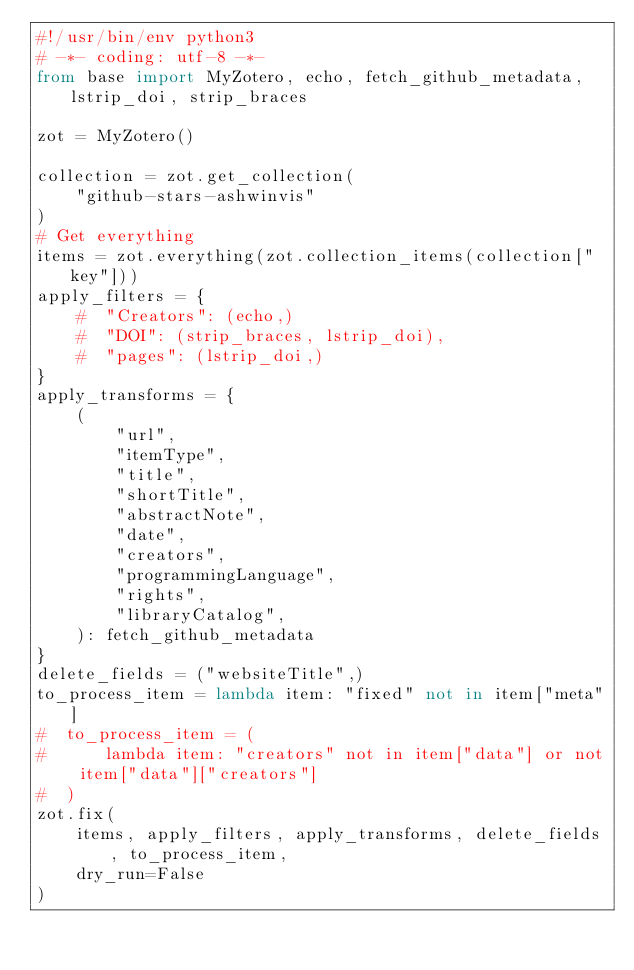Convert code to text. <code><loc_0><loc_0><loc_500><loc_500><_Python_>#!/usr/bin/env python3
# -*- coding: utf-8 -*-
from base import MyZotero, echo, fetch_github_metadata, lstrip_doi, strip_braces

zot = MyZotero()

collection = zot.get_collection(
    "github-stars-ashwinvis"
)
# Get everything
items = zot.everything(zot.collection_items(collection["key"]))
apply_filters = {
    #  "Creators": (echo,)
    #  "DOI": (strip_braces, lstrip_doi),
    #  "pages": (lstrip_doi,)
}
apply_transforms = {
    (
        "url",
        "itemType",
        "title",
        "shortTitle",
        "abstractNote",
        "date",
        "creators",
        "programmingLanguage",
        "rights",
        "libraryCatalog",
    ): fetch_github_metadata
}
delete_fields = ("websiteTitle",)
to_process_item = lambda item: "fixed" not in item["meta"]
#  to_process_item = (
#      lambda item: "creators" not in item["data"] or not item["data"]["creators"]
#  )
zot.fix(
    items, apply_filters, apply_transforms, delete_fields, to_process_item,
    dry_run=False
)
</code> 